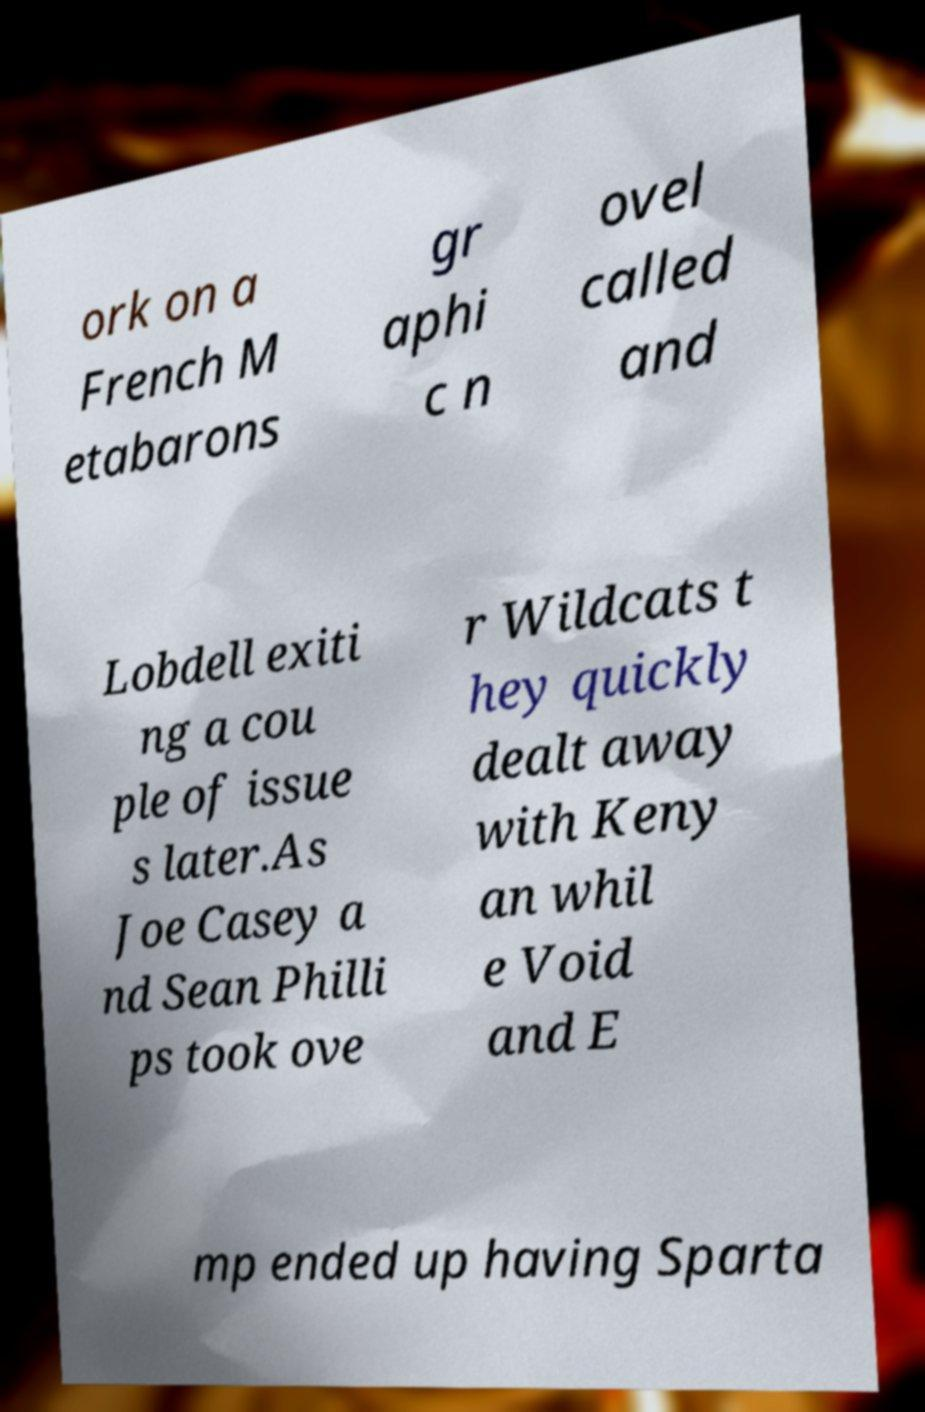What messages or text are displayed in this image? I need them in a readable, typed format. ork on a French M etabarons gr aphi c n ovel called and Lobdell exiti ng a cou ple of issue s later.As Joe Casey a nd Sean Philli ps took ove r Wildcats t hey quickly dealt away with Keny an whil e Void and E mp ended up having Sparta 